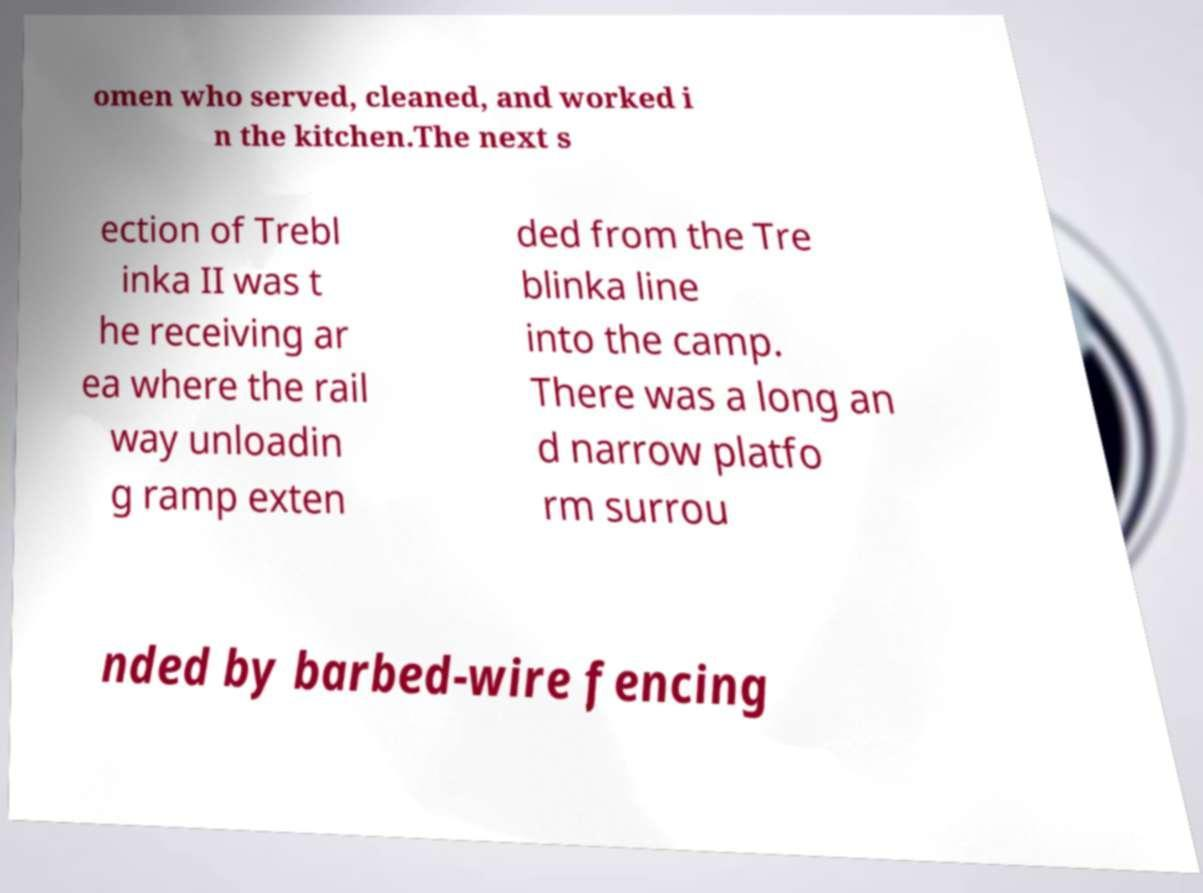Can you accurately transcribe the text from the provided image for me? omen who served, cleaned, and worked i n the kitchen.The next s ection of Trebl inka II was t he receiving ar ea where the rail way unloadin g ramp exten ded from the Tre blinka line into the camp. There was a long an d narrow platfo rm surrou nded by barbed-wire fencing 